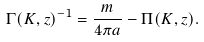Convert formula to latex. <formula><loc_0><loc_0><loc_500><loc_500>\Gamma ( K , z ) ^ { - 1 } = \frac { m } { 4 \pi a } - \Pi ( K , z ) .</formula> 